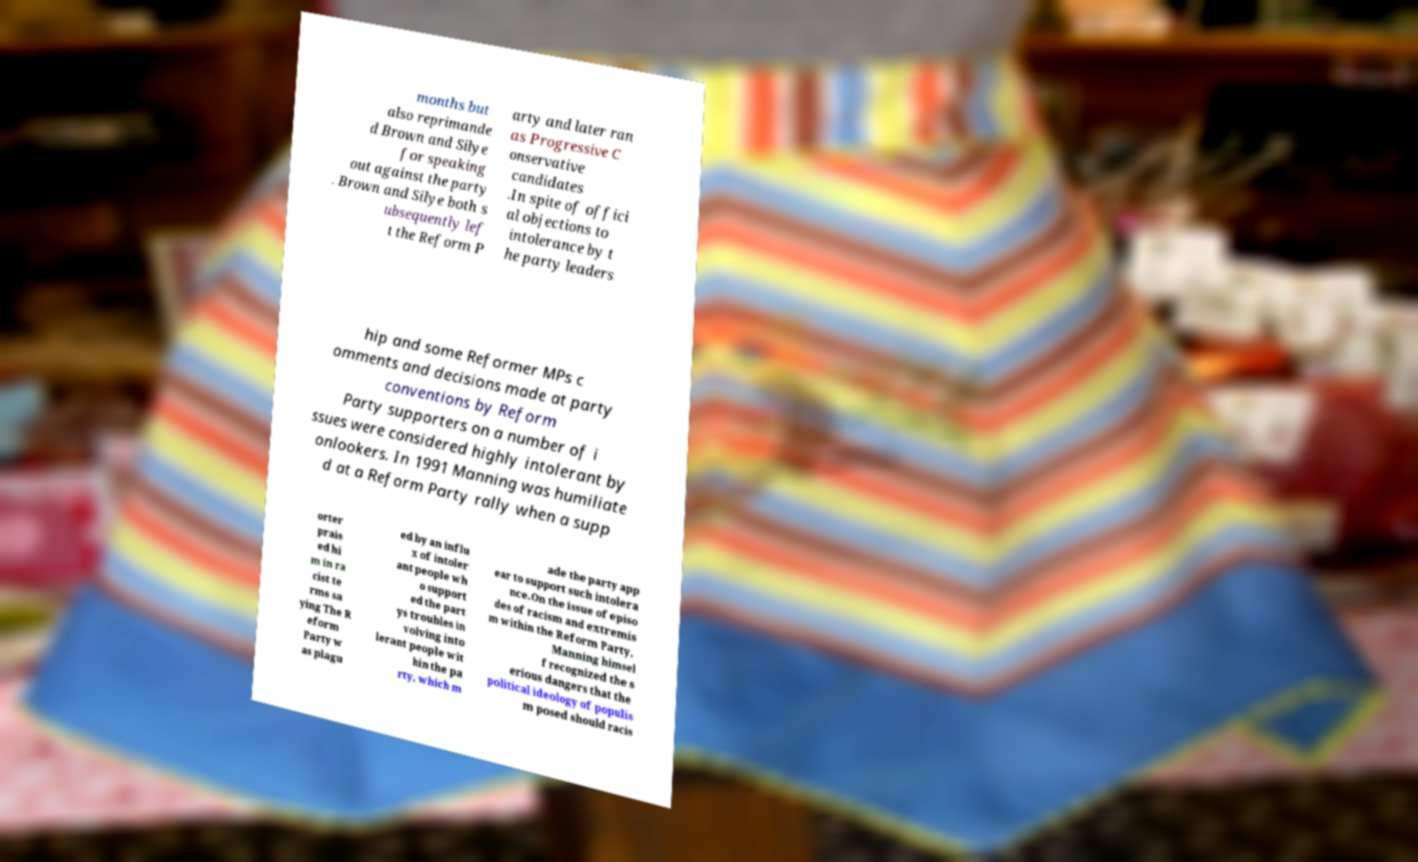Could you extract and type out the text from this image? months but also reprimande d Brown and Silye for speaking out against the party . Brown and Silye both s ubsequently lef t the Reform P arty and later ran as Progressive C onservative candidates .In spite of offici al objections to intolerance by t he party leaders hip and some Reformer MPs c omments and decisions made at party conventions by Reform Party supporters on a number of i ssues were considered highly intolerant by onlookers. In 1991 Manning was humiliate d at a Reform Party rally when a supp orter prais ed hi m in ra cist te rms sa ying The R eform Party w as plagu ed by an influ x of intoler ant people wh o support ed the part ys troubles in volving into lerant people wit hin the pa rty, which m ade the party app ear to support such intolera nce.On the issue of episo des of racism and extremis m within the Reform Party, Manning himsel f recognized the s erious dangers that the political ideology of populis m posed should racis 